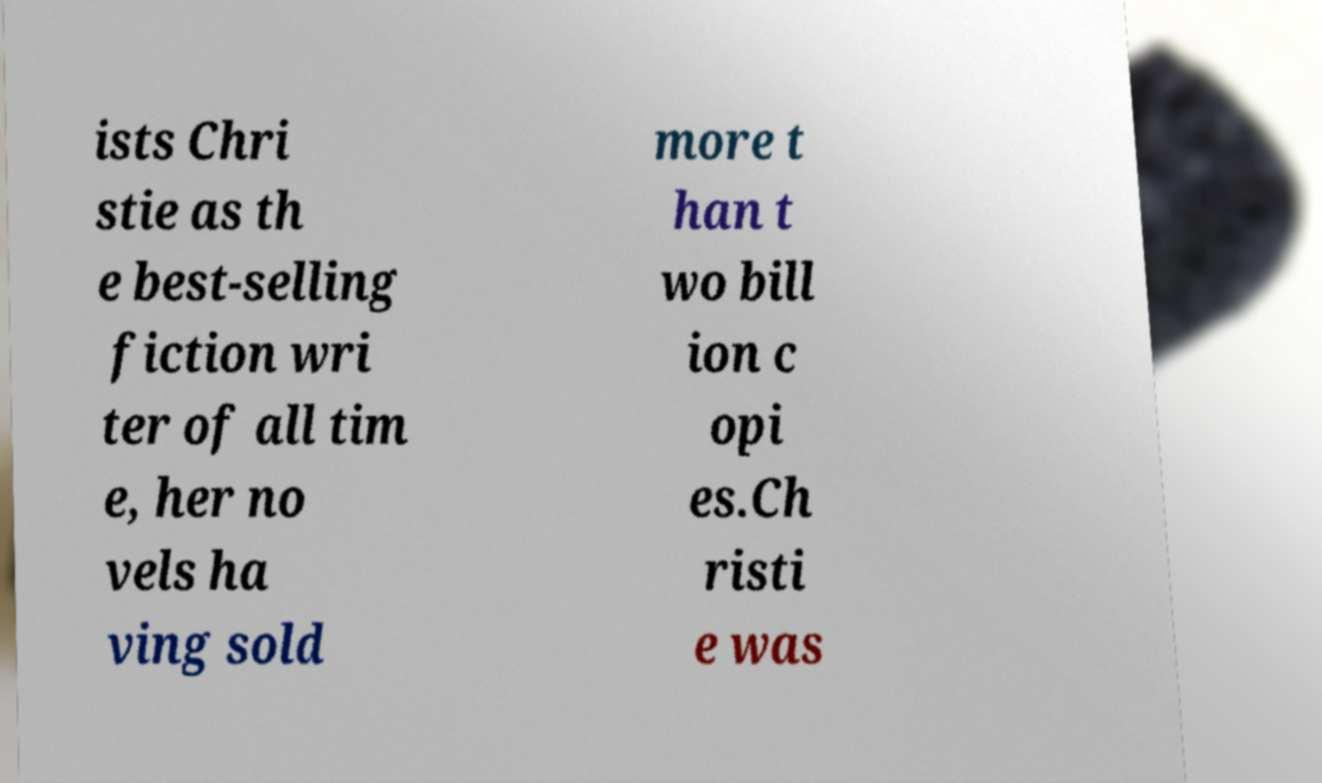Could you extract and type out the text from this image? ists Chri stie as th e best-selling fiction wri ter of all tim e, her no vels ha ving sold more t han t wo bill ion c opi es.Ch risti e was 